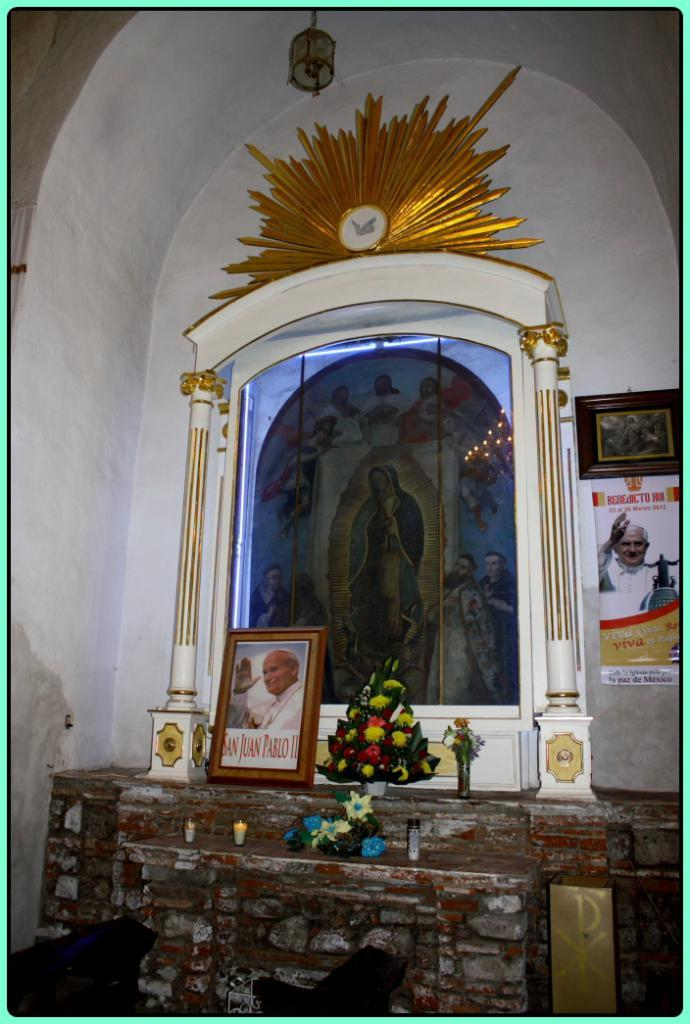What type of location is depicted in the image? The image shows an inside view of a building. What is located in the center of the image? There is a photo frame, a group of flowers, and a banner with some text in the center of the image. How many pillars can be seen in the image? There are two pillars in the image. What other object is present in the image? There is a lamp in the image. What type of vegetable is hanging from the ceiling in the image? There is no vegetable hanging from the ceiling in the image. What color is the copper feather in the image? There is no copper feather present in the image. 